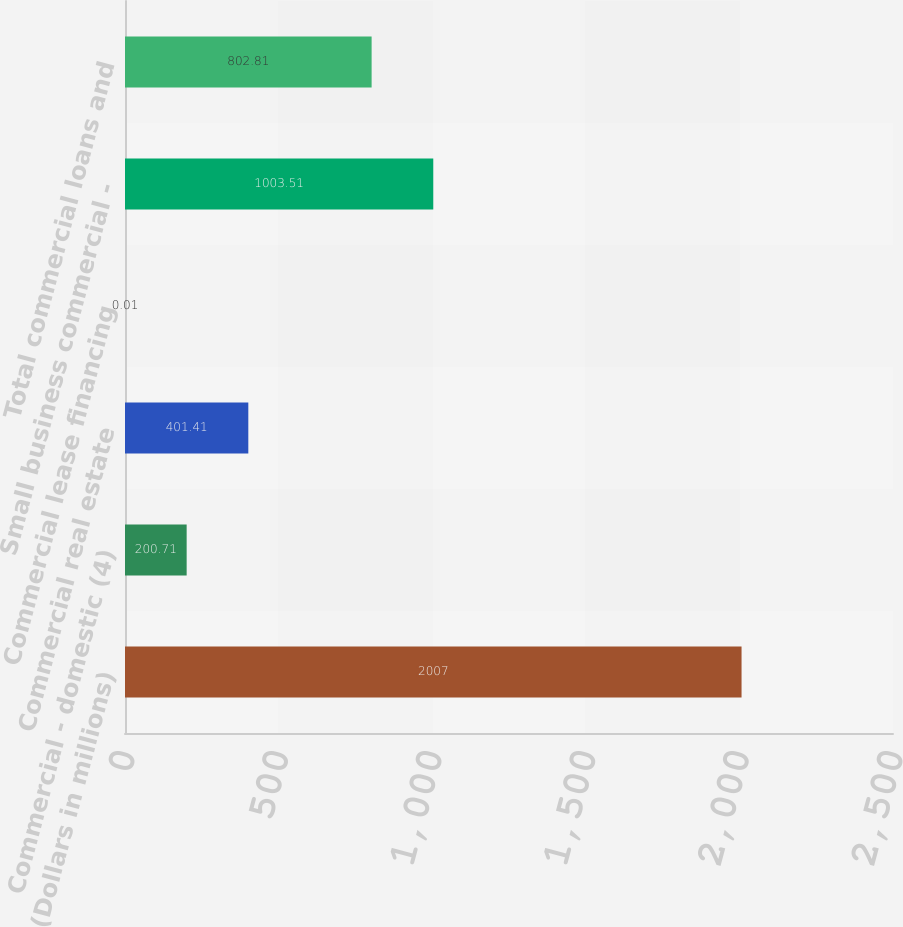Convert chart to OTSL. <chart><loc_0><loc_0><loc_500><loc_500><bar_chart><fcel>(Dollars in millions)<fcel>Commercial - domestic (4)<fcel>Commercial real estate<fcel>Commercial lease financing<fcel>Small business commercial -<fcel>Total commercial loans and<nl><fcel>2007<fcel>200.71<fcel>401.41<fcel>0.01<fcel>1003.51<fcel>802.81<nl></chart> 